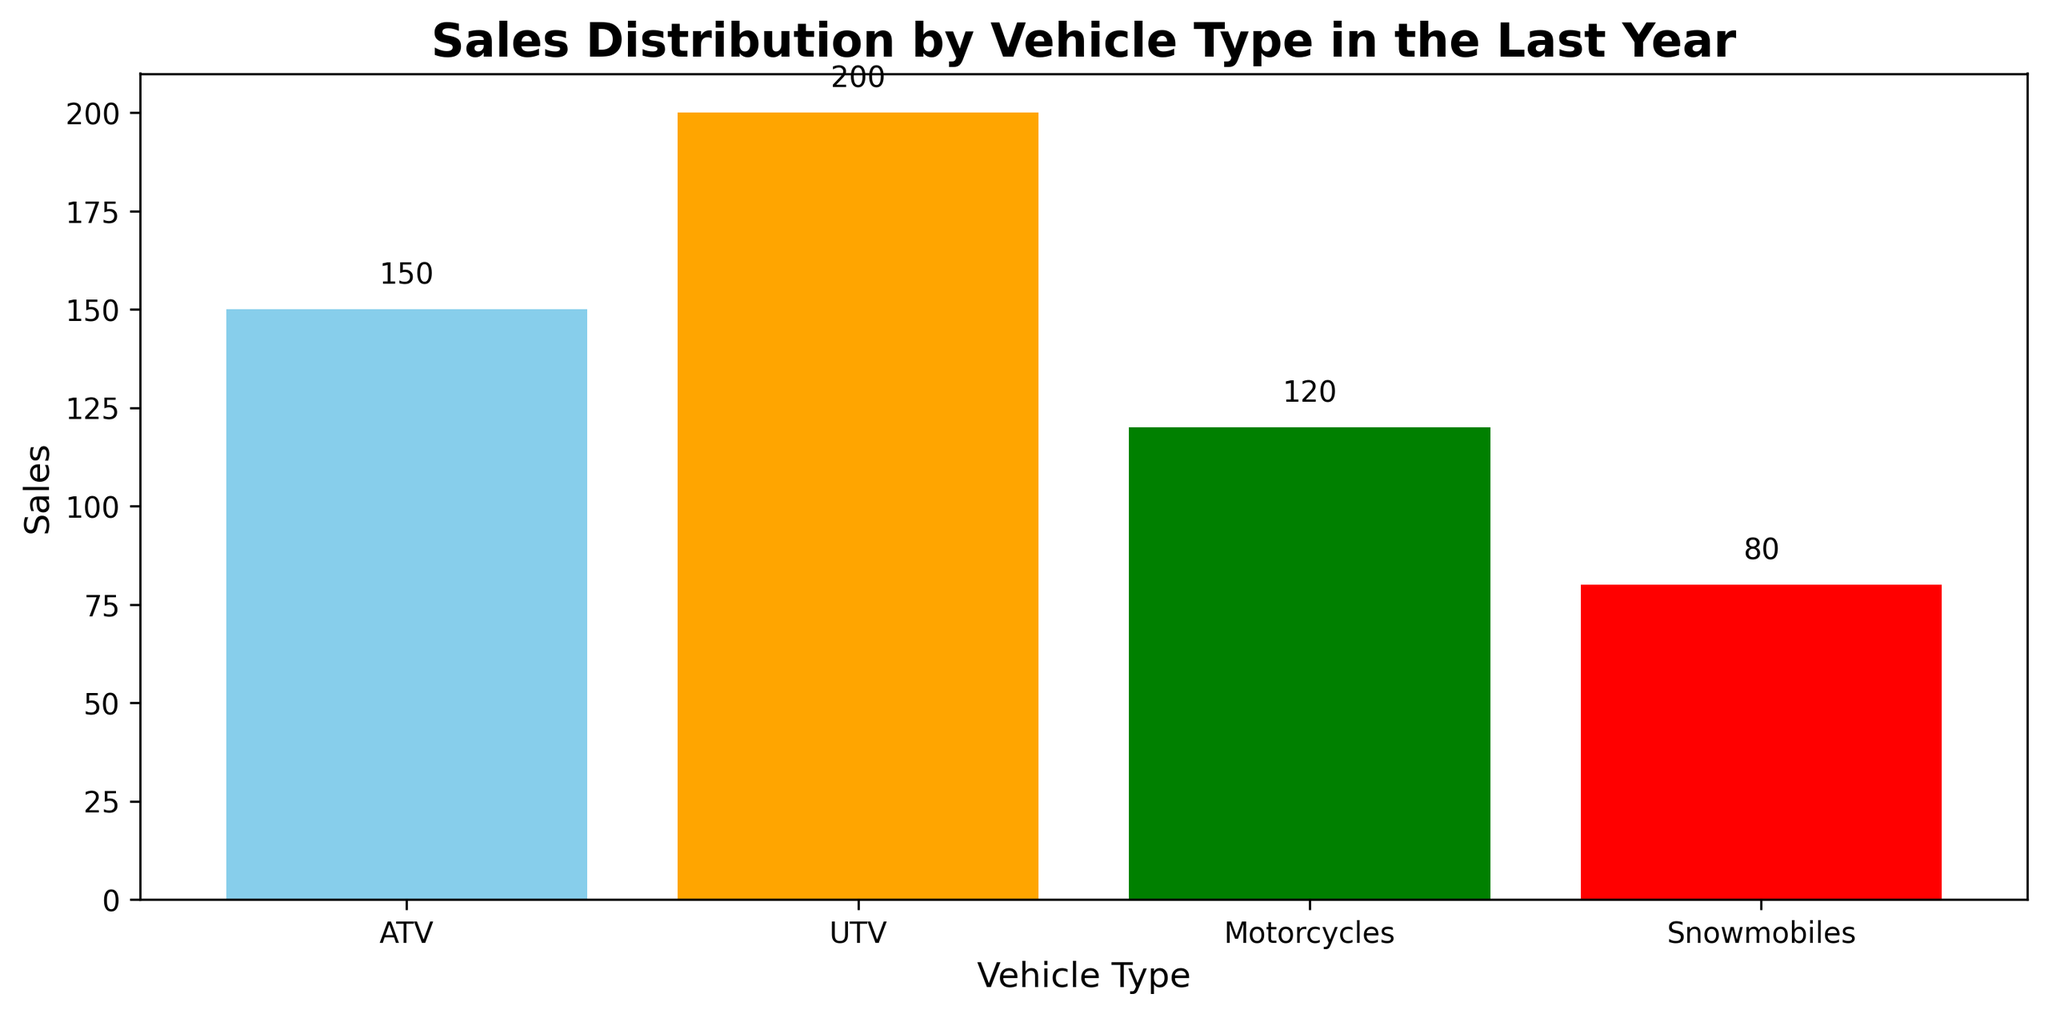What's the total number of sales for all vehicle types? To find the total number of sales, sum the sales figures for all vehicle types: 150 (ATV) + 200 (UTV) + 120 (Motorcycles) + 80 (Snowmobiles). The sum of these values is 550.
Answer: 550 Which vehicle type has the highest sales? By visually examining the heights of the bars in the chart, the UTV (orange bar) is the tallest, which indicates it has the highest sales.
Answer: UTV Which vehicle type has the lowest sales? By visually examining the heights of the bars in the chart, the Snowmobiles (red bar) is the shortest, which indicates it has the lowest sales.
Answer: Snowmobiles How much more in sales does the highest-selling vehicle type have compared to the lowest-selling vehicle type? Calculate the difference in sales between the UTV (200) and Snowmobiles (80). The difference is 200 - 80 = 120.
Answer: 120 What is the average sales per vehicle type? Sum the sales figures for each vehicle type: 150 (ATV) + 200 (UTV) + 120 (Motorcycles) + 80 (Snowmobiles) = 550. Then, divide this sum by the number of vehicle types (4). 550 / 4 = 137.5.
Answer: 137.5 Which two vehicle types combined have sales closest to 300? Calculate the sales for pairs of vehicle types: ATV + Motorcycles (150 + 120 = 270), ATV + Snowmobiles (150 + 80 = 230), UTV + Motorcycles (200 + 120 = 320), UTV + Snowmobiles (200 + 80 = 280), and Motorcycles + Snowmobiles (120 + 80 = 200). The pair UTV and Snowmobiles have a combined sales of 280, which is closest to 300.
Answer: UTV and Snowmobiles Is the total sales of ATVs and Motorcycles greater than the total sales of UTVs? Sum the sales of ATVs (150) and Motorcycles (120) to get 270. Compare this to the sales of UTVs (200). Since 270 is greater than 200, the total sales of ATVs and Motorcycles are greater than the total sales of UTVs.
Answer: Yes What is the ratio of sales between ATVs and UTVs? Divide the sales of ATVs by the sales of UTVs. 150 (ATVs) / 200 (UTVs) = 0.75.
Answer: 0.75 Are the combined sales of Motorcycles and Snowmobiles more than half of the total sales? First, find the combined sales of Motorcycles and Snowmobiles: 120 (Motorcycles) + 80 (Snowmobiles) = 200. Then, calculate half of the total sales: 550 / 2 = 275. Since 200 is less than 275, the combined sales of Motorcycles and Snowmobiles are not more than half of the total sales.
Answer: No What percentage of the total sales do UTVs account for? Divide the sales of UTVs by the total sales and multiply by 100: (200 / 550) * 100 ≈ 36.36%.
Answer: ≈36.36% 